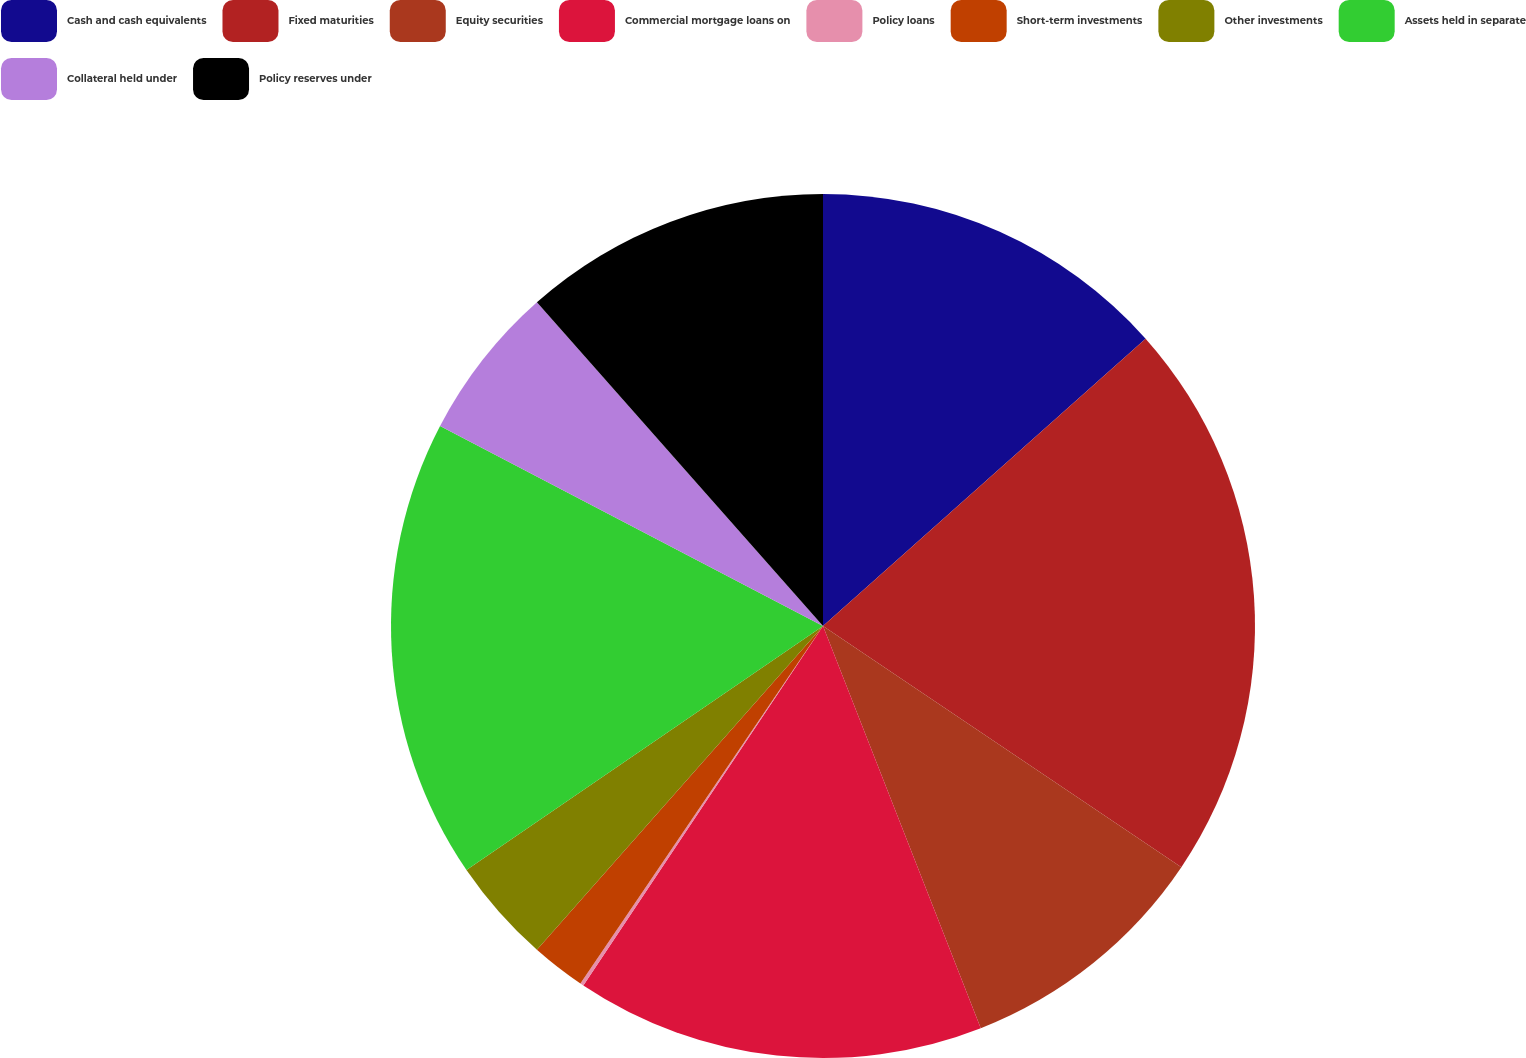Convert chart. <chart><loc_0><loc_0><loc_500><loc_500><pie_chart><fcel>Cash and cash equivalents<fcel>Fixed maturities<fcel>Equity securities<fcel>Commercial mortgage loans on<fcel>Policy loans<fcel>Short-term investments<fcel>Other investments<fcel>Assets held in separate<fcel>Collateral held under<fcel>Policy reserves under<nl><fcel>13.42%<fcel>21.01%<fcel>9.62%<fcel>15.31%<fcel>0.13%<fcel>2.03%<fcel>3.93%<fcel>17.21%<fcel>5.82%<fcel>11.52%<nl></chart> 